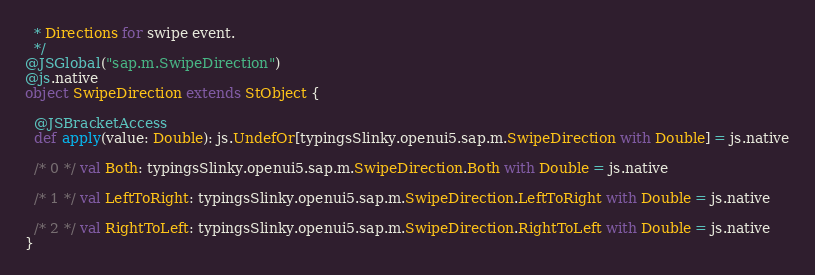<code> <loc_0><loc_0><loc_500><loc_500><_Scala_>  * Directions for swipe event.
  */
@JSGlobal("sap.m.SwipeDirection")
@js.native
object SwipeDirection extends StObject {
  
  @JSBracketAccess
  def apply(value: Double): js.UndefOr[typingsSlinky.openui5.sap.m.SwipeDirection with Double] = js.native
  
  /* 0 */ val Both: typingsSlinky.openui5.sap.m.SwipeDirection.Both with Double = js.native
  
  /* 1 */ val LeftToRight: typingsSlinky.openui5.sap.m.SwipeDirection.LeftToRight with Double = js.native
  
  /* 2 */ val RightToLeft: typingsSlinky.openui5.sap.m.SwipeDirection.RightToLeft with Double = js.native
}
</code> 